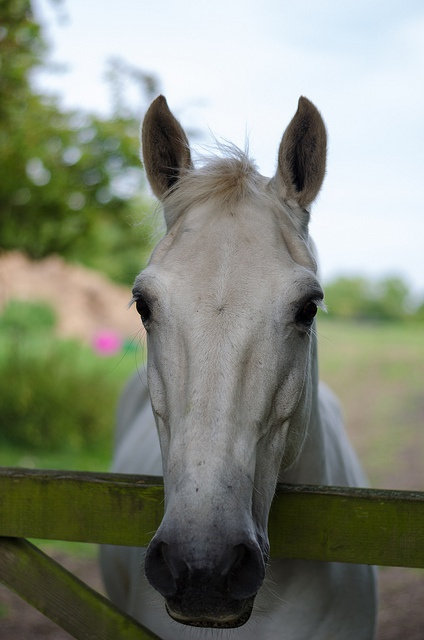Describe the objects in this image and their specific colors. I can see a horse in darkgreen, darkgray, gray, and black tones in this image. 